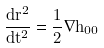Convert formula to latex. <formula><loc_0><loc_0><loc_500><loc_500>\frac { d \vec { r } ^ { 2 } } { d t ^ { 2 } } = \frac { 1 } { 2 } \vec { \nabla } h _ { 0 0 }</formula> 